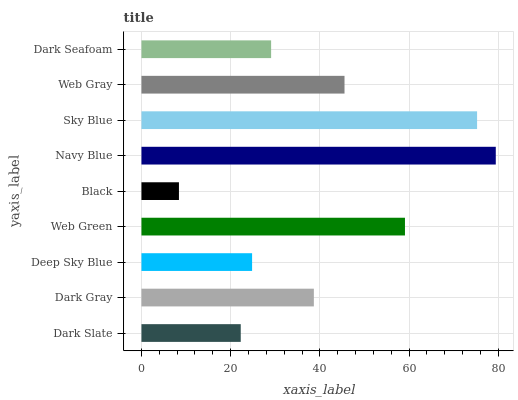Is Black the minimum?
Answer yes or no. Yes. Is Navy Blue the maximum?
Answer yes or no. Yes. Is Dark Gray the minimum?
Answer yes or no. No. Is Dark Gray the maximum?
Answer yes or no. No. Is Dark Gray greater than Dark Slate?
Answer yes or no. Yes. Is Dark Slate less than Dark Gray?
Answer yes or no. Yes. Is Dark Slate greater than Dark Gray?
Answer yes or no. No. Is Dark Gray less than Dark Slate?
Answer yes or no. No. Is Dark Gray the high median?
Answer yes or no. Yes. Is Dark Gray the low median?
Answer yes or no. Yes. Is Black the high median?
Answer yes or no. No. Is Sky Blue the low median?
Answer yes or no. No. 